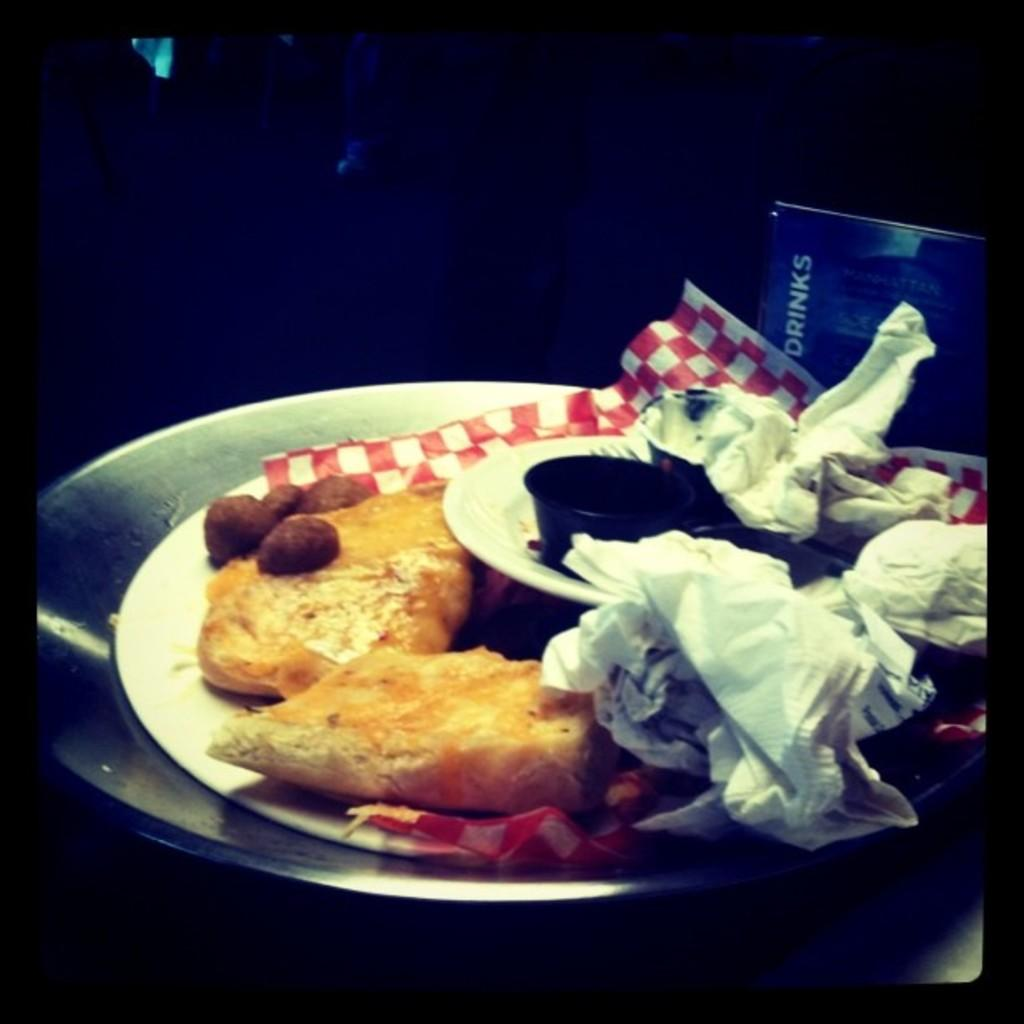What type of dishware is present in the image? There is a group of plates in the image. What else can be seen in the image besides the plates? There is a bowl containing food in the image. What is placed on the surface in the image? Papers are placed on the surface in the image. What can be seen in the background of the image? There is a board with text in the background of the image. How many lines are visible on the plates in the image? There are no lines visible on the plates in the image; they are smooth and unmarked. 